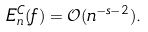Convert formula to latex. <formula><loc_0><loc_0><loc_500><loc_500>E _ { n } ^ { C } ( f ) = \mathcal { O } ( n ^ { - s - 2 } ) .</formula> 